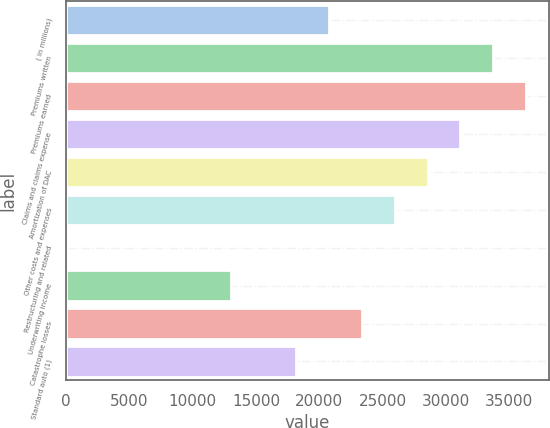Convert chart to OTSL. <chart><loc_0><loc_0><loc_500><loc_500><bar_chart><fcel>( in millions)<fcel>Premiums written<fcel>Premiums earned<fcel>Claims and claims expense<fcel>Amortization of DAC<fcel>Other costs and expenses<fcel>Restructuring and related<fcel>Underwriting income<fcel>Catastrophe losses<fcel>Standard auto (1)<nl><fcel>20770.6<fcel>33731.6<fcel>36323.8<fcel>31139.4<fcel>28547.2<fcel>25955<fcel>33<fcel>12994<fcel>23362.8<fcel>18178.4<nl></chart> 